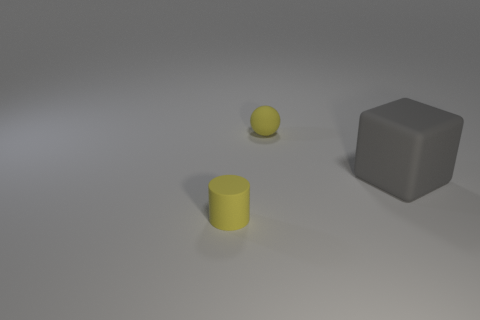There is a object that is right of the yellow sphere; is it the same size as the ball?
Make the answer very short. No. There is a small yellow thing that is in front of the tiny yellow object behind the gray block; what number of rubber things are right of it?
Offer a very short reply. 2. There is a thing that is in front of the yellow matte sphere and behind the small yellow cylinder; what size is it?
Offer a terse response. Large. There is a small yellow rubber sphere; what number of yellow objects are left of it?
Your answer should be very brief. 1. Is the number of small yellow objects to the right of the cylinder less than the number of large gray things left of the big matte thing?
Ensure brevity in your answer.  No. There is a yellow matte thing that is to the left of the small yellow thing that is behind the yellow rubber object that is in front of the tiny yellow ball; what shape is it?
Provide a succinct answer. Cylinder. What shape is the matte thing that is both left of the block and in front of the ball?
Keep it short and to the point. Cylinder. Is there a large gray object made of the same material as the tiny yellow cylinder?
Offer a terse response. Yes. The ball that is the same color as the tiny rubber cylinder is what size?
Your answer should be very brief. Small. What is the color of the rubber thing that is behind the large gray object?
Your answer should be compact. Yellow. 